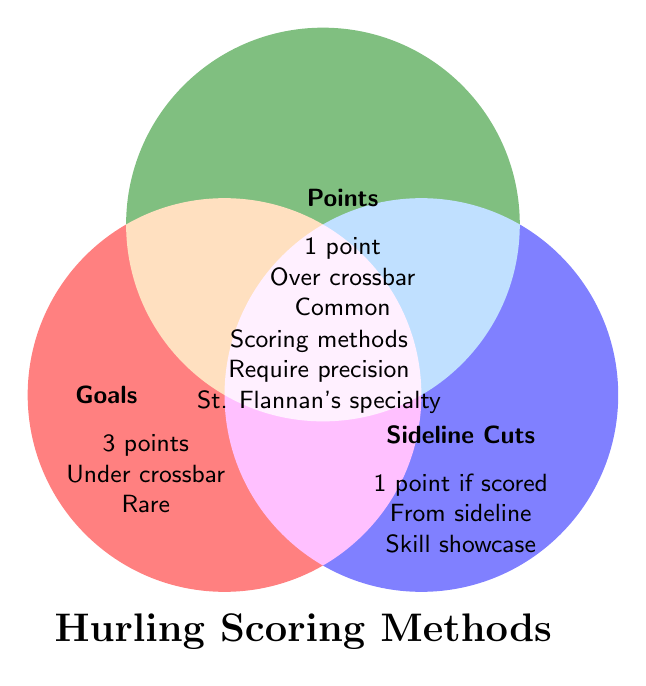What are the titles of the three scoring methods? The Venn diagram labels the scoring methods as Goals, Points, and Sideline Cuts.
Answer: Goals, Points, Sideline Cuts Where does the term "Skill showcase" appear? The term "Skill showcase" appears inside the circle labeled Sideline Cuts.
Answer: Sideline Cuts Which scoring method is indicated to be "Common"? The term "Common" appears inside the circle labeled Points.
Answer: Points Where is "3 points" associated? The text "3 points" is inside the circle labeled Goals.
Answer: Goals Which scoring methods have the same point value if they score? Both Points and Sideline Cuts are associated with scoring 1 point.
Answer: Points, Sideline Cuts What is indicated as "Rare" in the diagram? The term "Rare" is placed inside the circle labeled Goals, indicating that goals are rare.
Answer: Goals Which scoring methods are mentioned as requiring precision? The Venn diagram indicates that all scoring methods require precision in the overlap section.
Answer: All Where can you find the text "St. Flannan's specialty"? The text "St. Flannan's specialty" appears in the overlap section of the Venn diagram.
Answer: Overlap of all three Which of the scoring methods is associated with being taken from the sideline? The term "Taken from sideline" is inside the circle labeled Sideline Cuts.
Answer: Sideline Cuts What scoring method includes the description "Scored under crossbar"? The description "Scored under crossbar" is inside the circle labeled Goals.
Answer: Goals 